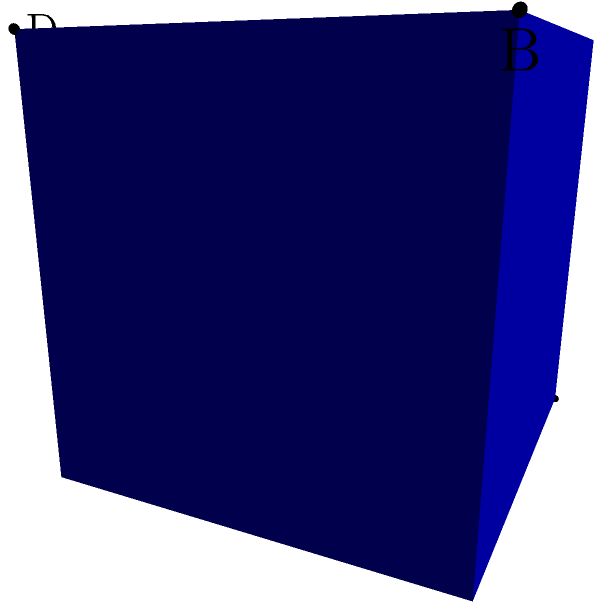In a high-end fashion boutique's dressing room, you need to place two makeup mirrors to create the perfect lighting setup. The room is represented by a 3D coordinate system where each unit represents 1 meter. Mirror A is placed at (0,0,0) and Mirror B at (1,1,1). To achieve optimal lighting, you need to place two spotlights. Spotlight C is at (0,1,0) and Spotlight D is at (1,0,1). What is the angle (in degrees) between the vectors $\vec{AB}$ and $\vec{CD}$? Let's approach this step-by-step:

1) First, we need to find the vectors $\vec{AB}$ and $\vec{CD}$:
   $\vec{AB} = B - A = (1,1,1) - (0,0,0) = (1,1,1)$
   $\vec{CD} = D - C = (1,0,1) - (0,1,0) = (1,-1,1)$

2) The angle between two vectors can be found using the dot product formula:
   $\cos \theta = \frac{\vec{AB} \cdot \vec{CD}}{|\vec{AB}| |\vec{CD}|}$

3) Let's calculate the dot product $\vec{AB} \cdot \vec{CD}$:
   $(1,1,1) \cdot (1,-1,1) = 1(-1) + 1(-1) + 1(1) = 1$

4) Now, let's calculate the magnitudes:
   $|\vec{AB}| = \sqrt{1^2 + 1^2 + 1^2} = \sqrt{3}$
   $|\vec{CD}| = \sqrt{1^2 + (-1)^2 + 1^2} = \sqrt{3}$

5) Plugging these into our formula:
   $\cos \theta = \frac{1}{\sqrt{3} \sqrt{3}} = \frac{1}{3}$

6) To get the angle, we need to take the inverse cosine (arccos):
   $\theta = \arccos(\frac{1}{3})$

7) Converting to degrees:
   $\theta \approx 70.53°$
Answer: 70.53° 